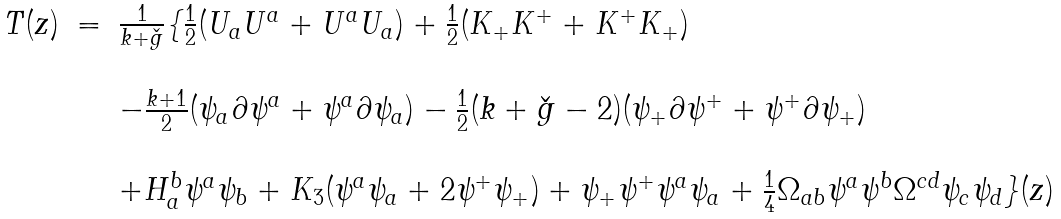Convert formula to latex. <formula><loc_0><loc_0><loc_500><loc_500>\begin{array} { l l l } T ( z ) & = & \frac { 1 } { k + \check { g } } \{ \frac { 1 } { 2 } ( U _ { a } U ^ { a } + U ^ { a } U _ { a } ) + \frac { 1 } { 2 } ( K _ { + } K ^ { + } + K ^ { + } K _ { + } ) \\ & & \\ & & - \frac { k + 1 } { 2 } ( \psi _ { a } \partial \psi ^ { a } + \psi ^ { a } \partial \psi _ { a } ) - \frac { 1 } { 2 } ( k + \check { g } - 2 ) ( \psi _ { + } \partial \psi ^ { + } + \psi ^ { + } \partial \psi _ { + } ) \\ & & \\ & & + H _ { a } ^ { b } \psi ^ { a } \psi _ { b } + K _ { 3 } ( \psi ^ { a } \psi _ { a } + 2 \psi ^ { + } \psi _ { + } ) + \psi _ { + } \psi ^ { + } \psi ^ { a } \psi _ { a } + \frac { 1 } { 4 } \Omega _ { a b } \psi ^ { a } \psi ^ { b } \Omega ^ { c d } \psi _ { c } \psi _ { d } \} ( z ) \end{array}</formula> 